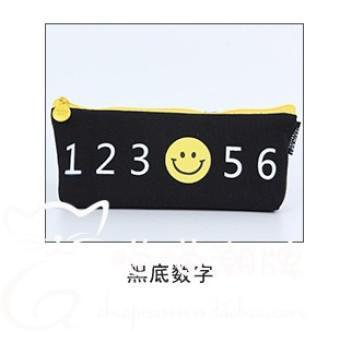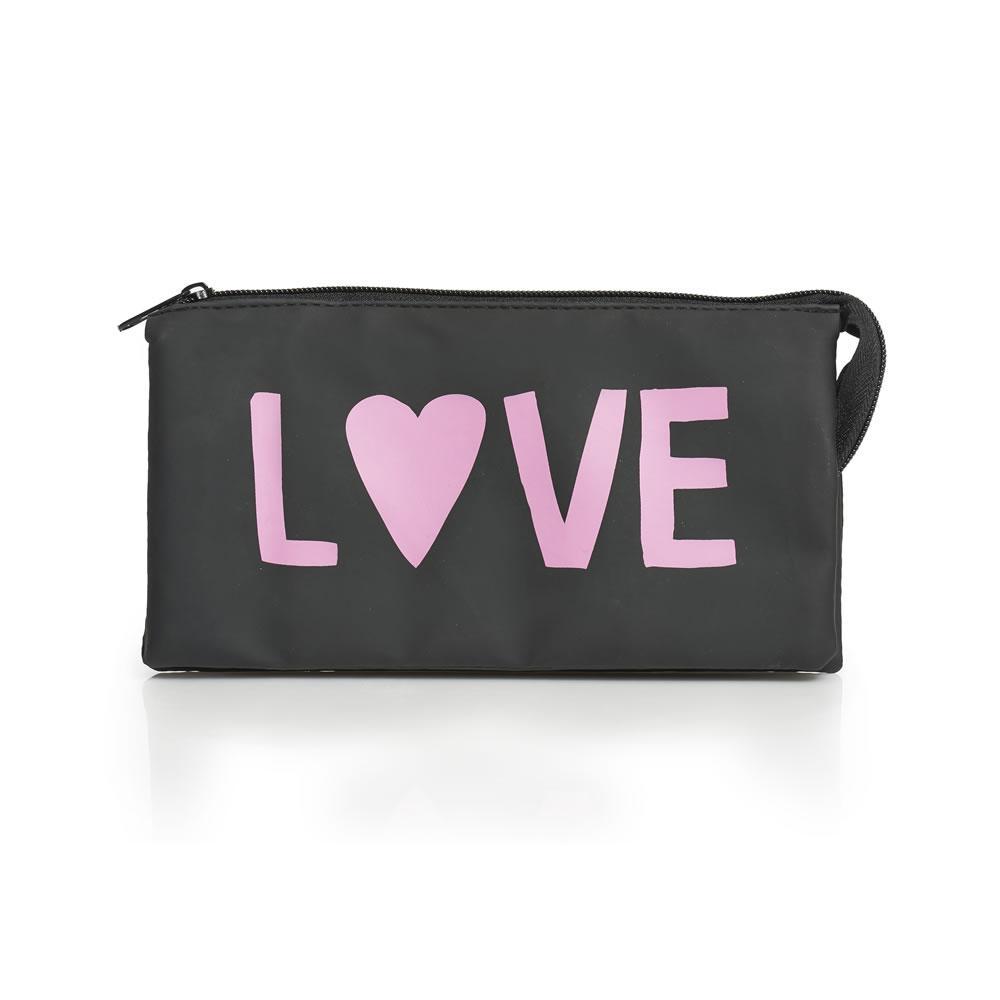The first image is the image on the left, the second image is the image on the right. Examine the images to the left and right. Is the description "There is the word animal that is printed in white and has a dot after the word in both images." accurate? Answer yes or no. No. The first image is the image on the left, the second image is the image on the right. Analyze the images presented: Is the assertion "Both pouches have the word """"animal"""" on them." valid? Answer yes or no. No. 